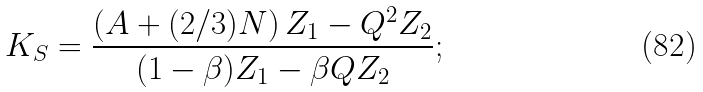<formula> <loc_0><loc_0><loc_500><loc_500>K _ { S } = \frac { \left ( A + ( 2 / 3 ) N \right ) Z _ { 1 } - Q ^ { 2 } Z _ { 2 } } { ( 1 - \beta ) Z _ { 1 } - \beta Q Z _ { 2 } } ;</formula> 